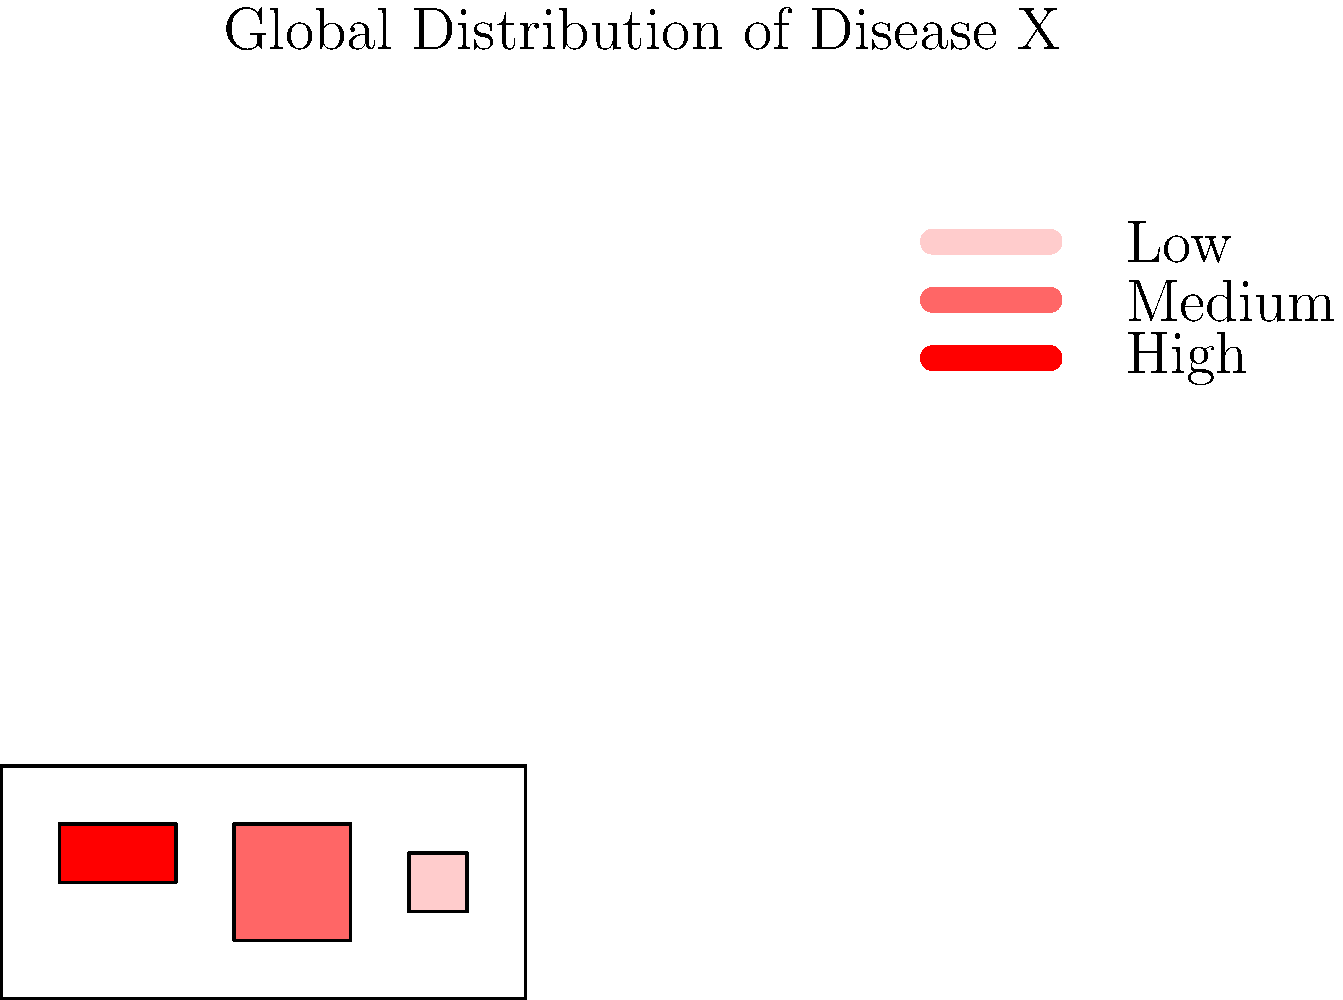Based on the global distribution map of Disease X, which region appears to have the highest prevalence, and how might this information influence public health strategies from a pharmacological perspective? 1. Analyze the map:
   - The map shows three distinct regions with different color intensities.
   - The color intensity represents the prevalence of Disease X.
   - Red (darkest) indicates high prevalence, medium red indicates moderate prevalence, and light red indicates low prevalence.

2. Identify the region with highest prevalence:
   - The region in the top-left quadrant (representing North America) is colored in the darkest red.
   - This indicates that North America has the highest prevalence of Disease X.

3. Consider pharmacological implications:
   - High prevalence suggests a greater need for therapeutic interventions.
   - This could influence drug development priorities and resource allocation.

4. Public health strategies from a pharmacological perspective:
   a) Increased drug production and distribution:
      - Ensure adequate supply of relevant medications in high-prevalence areas.
   b) Research and development:
      - Focus on developing new drugs or improving existing ones for Disease X.
   c) Pharmacovigilance:
      - Implement robust monitoring systems to track drug efficacy and side effects in the population.
   d) Personalized medicine:
      - Consider genetic factors that might influence drug response in the affected population.
   e) Preventive pharmacology:
      - Develop and promote prophylactic treatments if applicable.
   f) Drug resistance management:
      - Monitor and address potential drug resistance issues due to high use in the region.

5. Global health considerations:
   - While focusing on high-prevalence areas, maintain a global perspective to prevent spread and address the disease in all affected regions.
Answer: North America; prioritize drug development, increase production/distribution, enhance pharmacovigilance, and focus on personalized and preventive pharmacological approaches. 